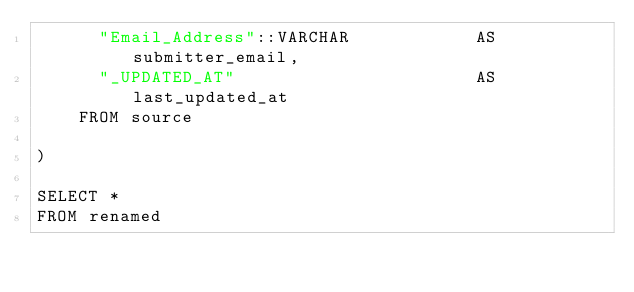<code> <loc_0><loc_0><loc_500><loc_500><_SQL_>      "Email_Address"::VARCHAR            AS submitter_email,
      "_UPDATED_AT"                       AS last_updated_at
    FROM source

)

SELECT *
FROM renamed


</code> 